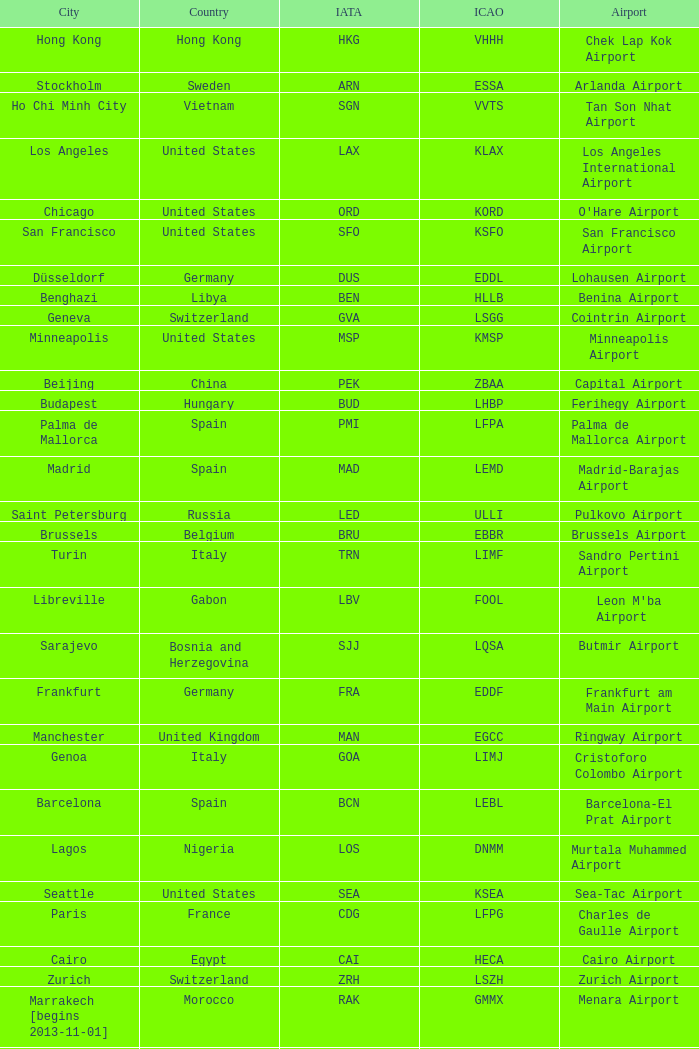Which city has the IATA SSG? Malabo. 